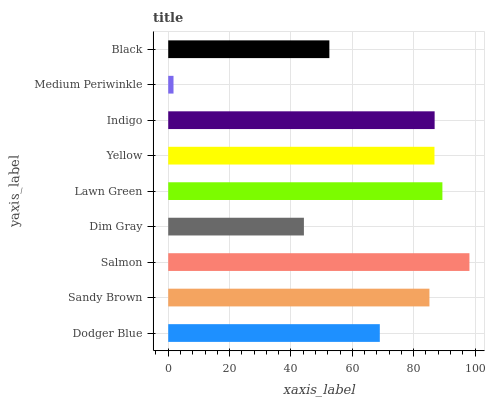Is Medium Periwinkle the minimum?
Answer yes or no. Yes. Is Salmon the maximum?
Answer yes or no. Yes. Is Sandy Brown the minimum?
Answer yes or no. No. Is Sandy Brown the maximum?
Answer yes or no. No. Is Sandy Brown greater than Dodger Blue?
Answer yes or no. Yes. Is Dodger Blue less than Sandy Brown?
Answer yes or no. Yes. Is Dodger Blue greater than Sandy Brown?
Answer yes or no. No. Is Sandy Brown less than Dodger Blue?
Answer yes or no. No. Is Sandy Brown the high median?
Answer yes or no. Yes. Is Sandy Brown the low median?
Answer yes or no. Yes. Is Salmon the high median?
Answer yes or no. No. Is Dim Gray the low median?
Answer yes or no. No. 